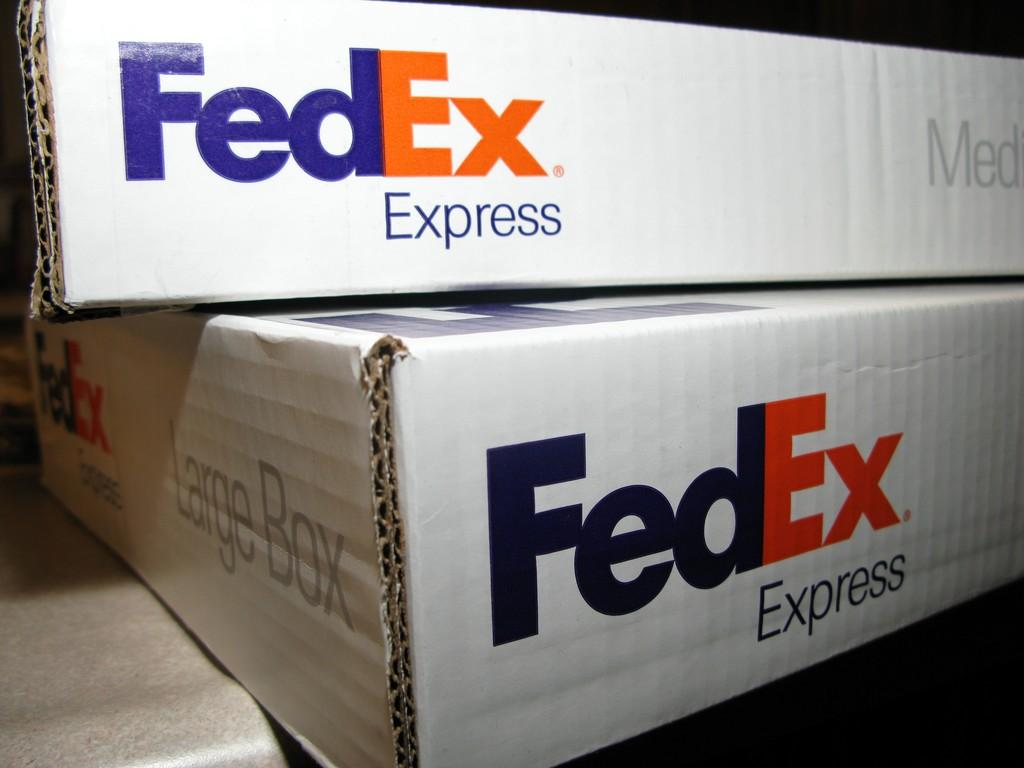How many FedEx boxes are in the image? There are two FedEx boxes in the image. Can you describe the size of the boxes? One of the boxes is large, and the other box is of medium size. What color is the vein in the image? There is no vein present in the image. Can you describe the actions of the fireman in the image? There is no fireman present in the image. 